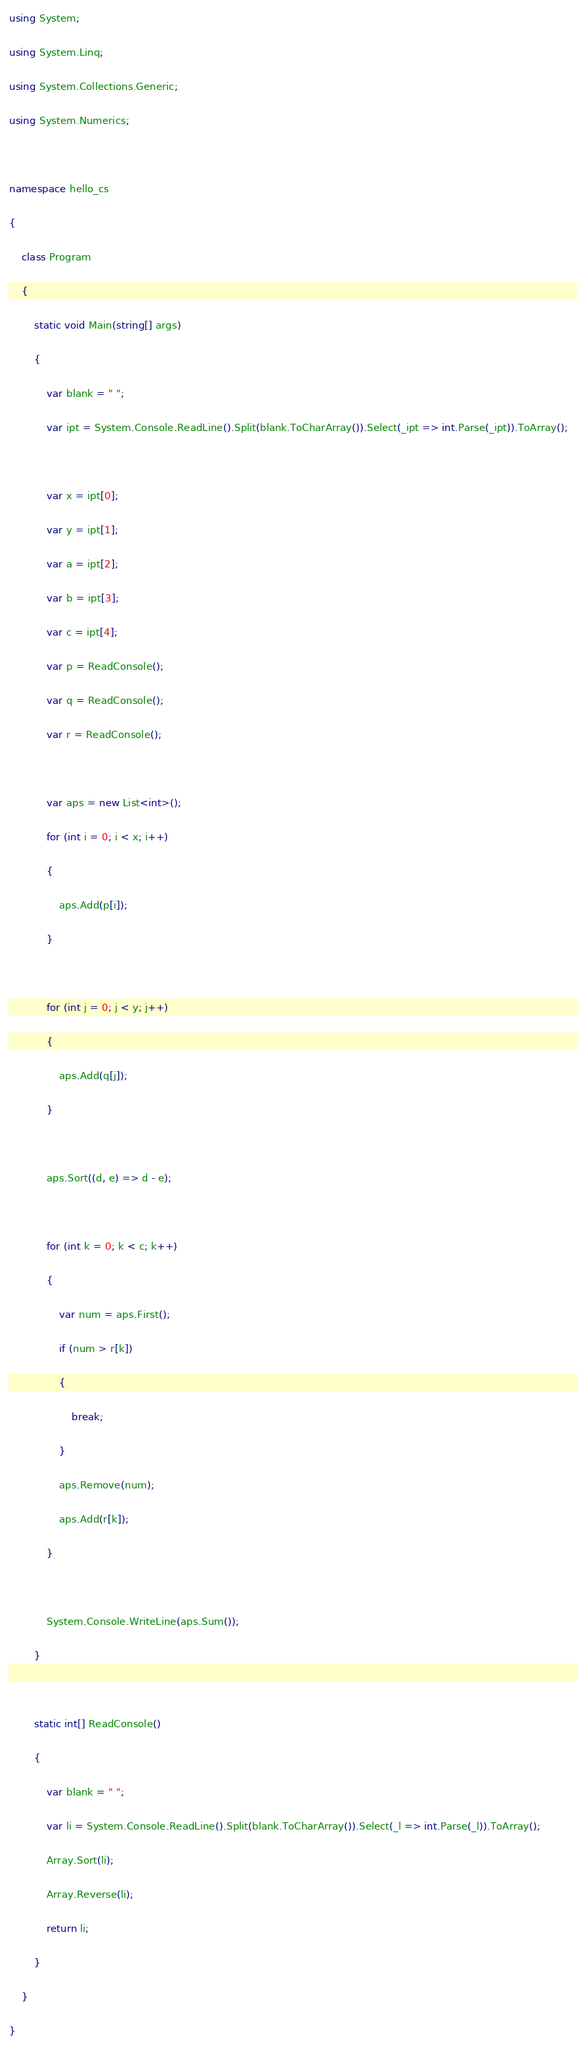Convert code to text. <code><loc_0><loc_0><loc_500><loc_500><_C#_>using System;

using System.Linq;

using System.Collections.Generic;

using System.Numerics;



namespace hello_cs

{

    class Program

    {

        static void Main(string[] args)

        {

            var blank = " ";

            var ipt = System.Console.ReadLine().Split(blank.ToCharArray()).Select(_ipt => int.Parse(_ipt)).ToArray();



            var x = ipt[0];

            var y = ipt[1];

            var a = ipt[2];

            var b = ipt[3];

            var c = ipt[4];

            var p = ReadConsole();

            var q = ReadConsole();

            var r = ReadConsole();



            var aps = new List<int>();

            for (int i = 0; i < x; i++)

            {

                aps.Add(p[i]);

            }



            for (int j = 0; j < y; j++)

            {

                aps.Add(q[j]);

            }



            aps.Sort((d, e) => d - e);



            for (int k = 0; k < c; k++)

            {

                var num = aps.First();

                if (num > r[k])

                {

                    break;

                }

                aps.Remove(num);

                aps.Add(r[k]);

            }



            System.Console.WriteLine(aps.Sum());

        }



        static int[] ReadConsole()

        {

            var blank = " ";

            var li = System.Console.ReadLine().Split(blank.ToCharArray()).Select(_l => int.Parse(_l)).ToArray();

            Array.Sort(li);

            Array.Reverse(li);

            return li;

        }

    }

}

</code> 